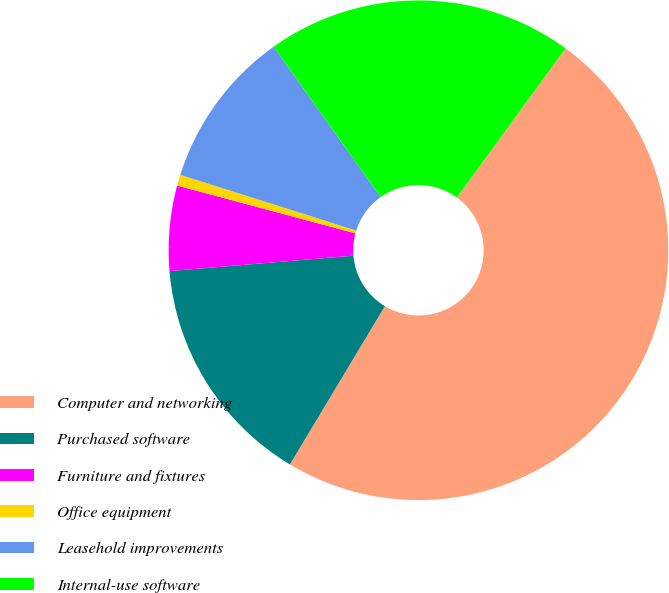Convert chart to OTSL. <chart><loc_0><loc_0><loc_500><loc_500><pie_chart><fcel>Computer and networking<fcel>Purchased software<fcel>Furniture and fixtures<fcel>Office equipment<fcel>Leasehold improvements<fcel>Internal-use software<nl><fcel>48.58%<fcel>15.07%<fcel>5.5%<fcel>0.71%<fcel>10.28%<fcel>19.86%<nl></chart> 